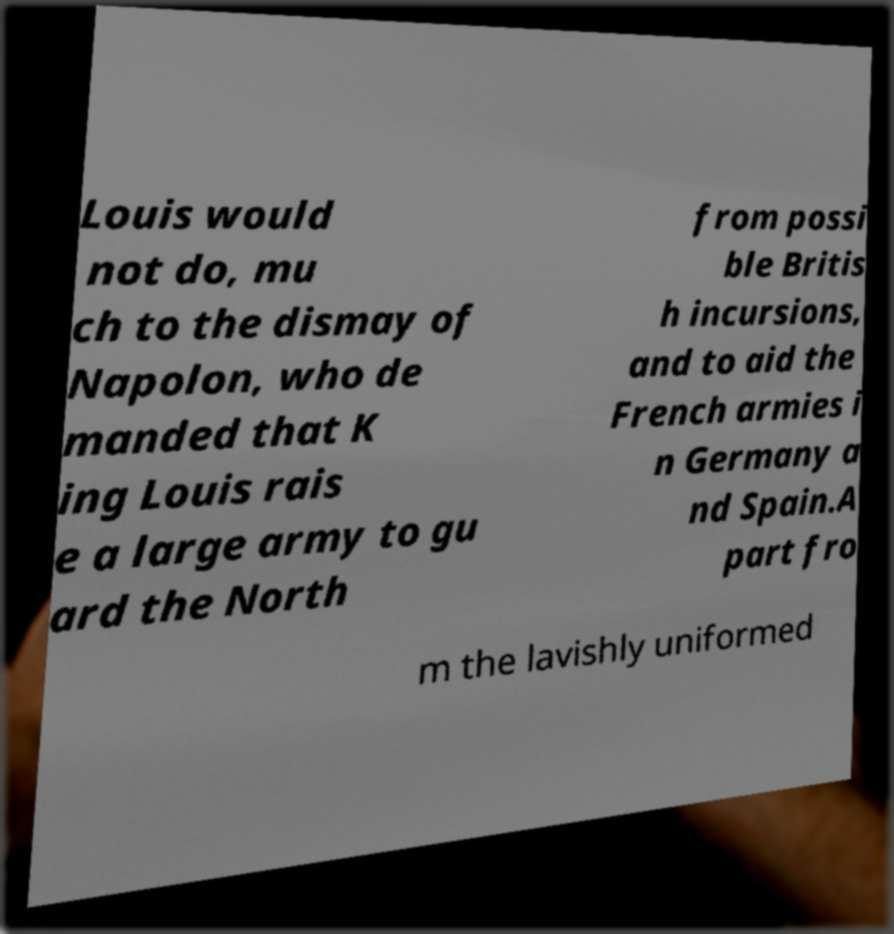Could you assist in decoding the text presented in this image and type it out clearly? Louis would not do, mu ch to the dismay of Napolon, who de manded that K ing Louis rais e a large army to gu ard the North from possi ble Britis h incursions, and to aid the French armies i n Germany a nd Spain.A part fro m the lavishly uniformed 